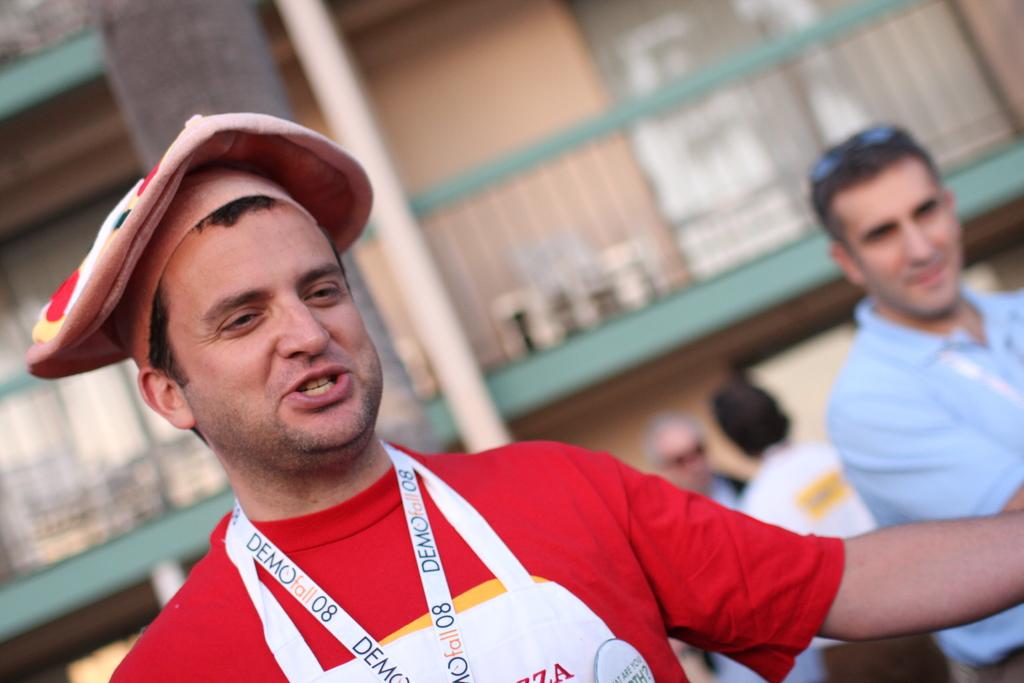What is written on the lanyard?
Offer a very short reply. Demo fall 08. 